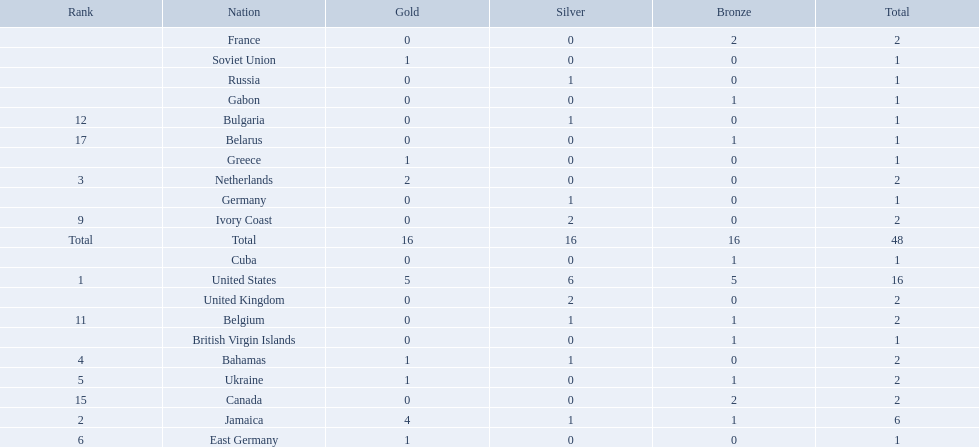Can you give me this table in json format? {'header': ['Rank', 'Nation', 'Gold', 'Silver', 'Bronze', 'Total'], 'rows': [['', 'France', '0', '0', '2', '2'], ['', 'Soviet Union', '1', '0', '0', '1'], ['', 'Russia', '0', '1', '0', '1'], ['', 'Gabon', '0', '0', '1', '1'], ['12', 'Bulgaria', '0', '1', '0', '1'], ['17', 'Belarus', '0', '0', '1', '1'], ['', 'Greece', '1', '0', '0', '1'], ['3', 'Netherlands', '2', '0', '0', '2'], ['', 'Germany', '0', '1', '0', '1'], ['9', 'Ivory Coast', '0', '2', '0', '2'], ['Total', 'Total', '16', '16', '16', '48'], ['', 'Cuba', '0', '0', '1', '1'], ['1', 'United States', '5', '6', '5', '16'], ['', 'United Kingdom', '0', '2', '0', '2'], ['11', 'Belgium', '0', '1', '1', '2'], ['', 'British Virgin Islands', '0', '0', '1', '1'], ['4', 'Bahamas', '1', '1', '0', '2'], ['5', 'Ukraine', '1', '0', '1', '2'], ['15', 'Canada', '0', '0', '2', '2'], ['2', 'Jamaica', '4', '1', '1', '6'], ['6', 'East Germany', '1', '0', '0', '1']]} What was the largest number of medals won by any country? 16. Which country won that many medals? United States. What country won the most medals? United States. How many medals did the us win? 16. What is the most medals (after 16) that were won by a country? 6. Which country won 6 medals? Jamaica. Which countries participated? United States, Jamaica, Netherlands, Bahamas, Ukraine, East Germany, Greece, Soviet Union, Ivory Coast, United Kingdom, Belgium, Bulgaria, Russia, Germany, Canada, France, Belarus, Cuba, Gabon, British Virgin Islands. How many gold medals were won by each? 5, 4, 2, 1, 1, 1, 1, 1, 0, 0, 0, 0, 0, 0, 0, 0, 0, 0, 0, 0. And which country won the most? United States. 